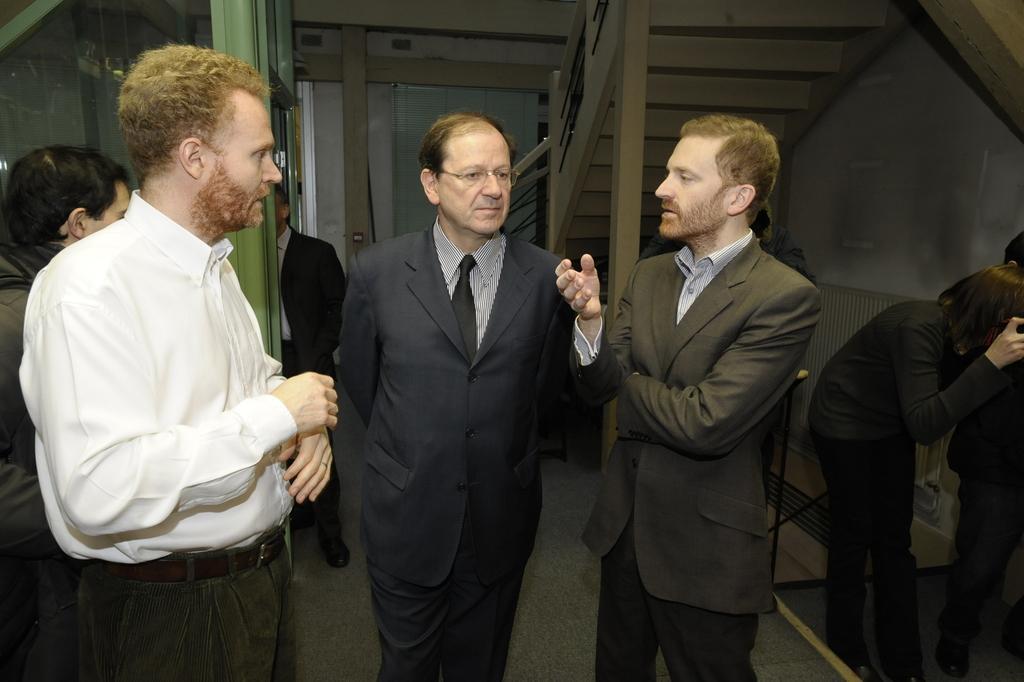Describe this image in one or two sentences. In this picture we can see some people are standing, on the right side we can see staircase, a person on the right side is holding something, two persons in the front wore suits. 